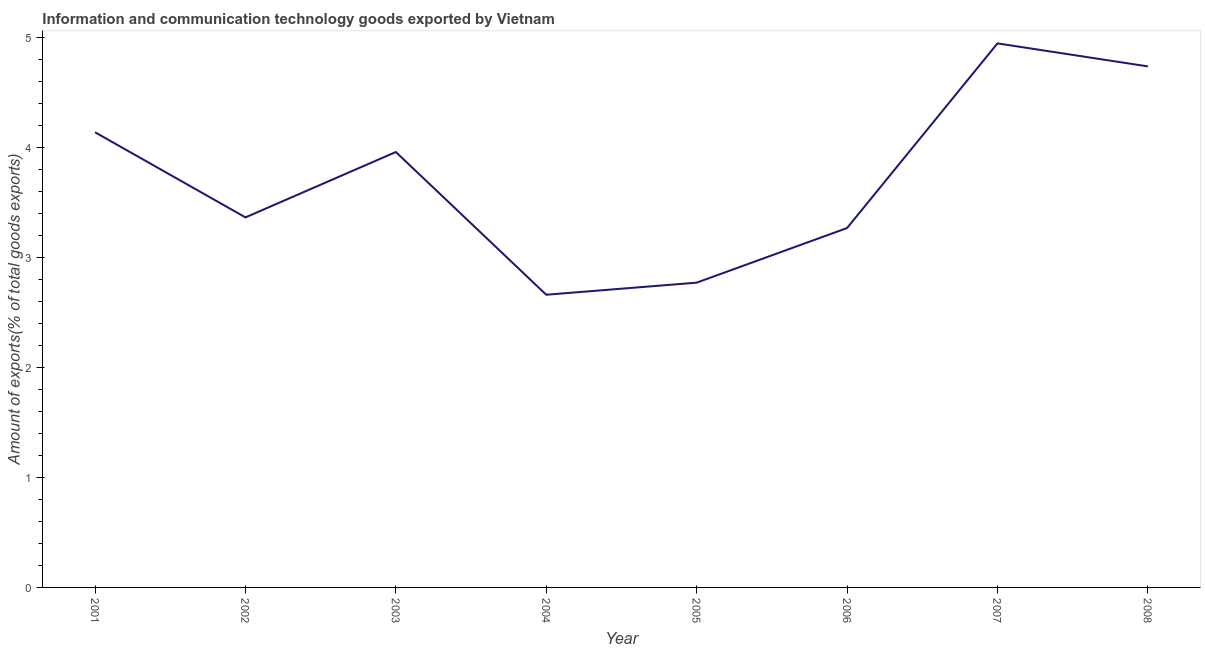What is the amount of ict goods exports in 2001?
Offer a very short reply. 4.14. Across all years, what is the maximum amount of ict goods exports?
Provide a succinct answer. 4.95. Across all years, what is the minimum amount of ict goods exports?
Offer a very short reply. 2.66. What is the sum of the amount of ict goods exports?
Offer a terse response. 29.85. What is the difference between the amount of ict goods exports in 2005 and 2008?
Your answer should be compact. -1.97. What is the average amount of ict goods exports per year?
Provide a succinct answer. 3.73. What is the median amount of ict goods exports?
Provide a succinct answer. 3.66. What is the ratio of the amount of ict goods exports in 2003 to that in 2004?
Make the answer very short. 1.49. What is the difference between the highest and the second highest amount of ict goods exports?
Offer a terse response. 0.21. Is the sum of the amount of ict goods exports in 2001 and 2006 greater than the maximum amount of ict goods exports across all years?
Your answer should be compact. Yes. What is the difference between the highest and the lowest amount of ict goods exports?
Offer a terse response. 2.29. In how many years, is the amount of ict goods exports greater than the average amount of ict goods exports taken over all years?
Provide a short and direct response. 4. Does the amount of ict goods exports monotonically increase over the years?
Offer a terse response. No. How many lines are there?
Offer a very short reply. 1. What is the difference between two consecutive major ticks on the Y-axis?
Provide a short and direct response. 1. Are the values on the major ticks of Y-axis written in scientific E-notation?
Your response must be concise. No. Does the graph contain any zero values?
Provide a short and direct response. No. What is the title of the graph?
Make the answer very short. Information and communication technology goods exported by Vietnam. What is the label or title of the X-axis?
Your answer should be very brief. Year. What is the label or title of the Y-axis?
Your answer should be very brief. Amount of exports(% of total goods exports). What is the Amount of exports(% of total goods exports) in 2001?
Make the answer very short. 4.14. What is the Amount of exports(% of total goods exports) of 2002?
Provide a succinct answer. 3.37. What is the Amount of exports(% of total goods exports) of 2003?
Make the answer very short. 3.96. What is the Amount of exports(% of total goods exports) of 2004?
Ensure brevity in your answer.  2.66. What is the Amount of exports(% of total goods exports) of 2005?
Provide a short and direct response. 2.77. What is the Amount of exports(% of total goods exports) in 2006?
Your answer should be very brief. 3.27. What is the Amount of exports(% of total goods exports) of 2007?
Keep it short and to the point. 4.95. What is the Amount of exports(% of total goods exports) in 2008?
Offer a very short reply. 4.74. What is the difference between the Amount of exports(% of total goods exports) in 2001 and 2002?
Make the answer very short. 0.77. What is the difference between the Amount of exports(% of total goods exports) in 2001 and 2003?
Your answer should be very brief. 0.18. What is the difference between the Amount of exports(% of total goods exports) in 2001 and 2004?
Your response must be concise. 1.48. What is the difference between the Amount of exports(% of total goods exports) in 2001 and 2005?
Your response must be concise. 1.37. What is the difference between the Amount of exports(% of total goods exports) in 2001 and 2006?
Your answer should be compact. 0.87. What is the difference between the Amount of exports(% of total goods exports) in 2001 and 2007?
Offer a very short reply. -0.81. What is the difference between the Amount of exports(% of total goods exports) in 2001 and 2008?
Give a very brief answer. -0.6. What is the difference between the Amount of exports(% of total goods exports) in 2002 and 2003?
Offer a very short reply. -0.59. What is the difference between the Amount of exports(% of total goods exports) in 2002 and 2004?
Your answer should be compact. 0.7. What is the difference between the Amount of exports(% of total goods exports) in 2002 and 2005?
Provide a short and direct response. 0.59. What is the difference between the Amount of exports(% of total goods exports) in 2002 and 2006?
Keep it short and to the point. 0.1. What is the difference between the Amount of exports(% of total goods exports) in 2002 and 2007?
Your response must be concise. -1.58. What is the difference between the Amount of exports(% of total goods exports) in 2002 and 2008?
Provide a short and direct response. -1.37. What is the difference between the Amount of exports(% of total goods exports) in 2003 and 2004?
Keep it short and to the point. 1.3. What is the difference between the Amount of exports(% of total goods exports) in 2003 and 2005?
Give a very brief answer. 1.19. What is the difference between the Amount of exports(% of total goods exports) in 2003 and 2006?
Offer a terse response. 0.69. What is the difference between the Amount of exports(% of total goods exports) in 2003 and 2007?
Ensure brevity in your answer.  -0.99. What is the difference between the Amount of exports(% of total goods exports) in 2003 and 2008?
Your answer should be very brief. -0.78. What is the difference between the Amount of exports(% of total goods exports) in 2004 and 2005?
Offer a terse response. -0.11. What is the difference between the Amount of exports(% of total goods exports) in 2004 and 2006?
Keep it short and to the point. -0.61. What is the difference between the Amount of exports(% of total goods exports) in 2004 and 2007?
Provide a short and direct response. -2.29. What is the difference between the Amount of exports(% of total goods exports) in 2004 and 2008?
Provide a short and direct response. -2.08. What is the difference between the Amount of exports(% of total goods exports) in 2005 and 2006?
Your answer should be compact. -0.5. What is the difference between the Amount of exports(% of total goods exports) in 2005 and 2007?
Your response must be concise. -2.18. What is the difference between the Amount of exports(% of total goods exports) in 2005 and 2008?
Your answer should be compact. -1.97. What is the difference between the Amount of exports(% of total goods exports) in 2006 and 2007?
Your response must be concise. -1.68. What is the difference between the Amount of exports(% of total goods exports) in 2006 and 2008?
Your answer should be compact. -1.47. What is the difference between the Amount of exports(% of total goods exports) in 2007 and 2008?
Your answer should be very brief. 0.21. What is the ratio of the Amount of exports(% of total goods exports) in 2001 to that in 2002?
Ensure brevity in your answer.  1.23. What is the ratio of the Amount of exports(% of total goods exports) in 2001 to that in 2003?
Your response must be concise. 1.04. What is the ratio of the Amount of exports(% of total goods exports) in 2001 to that in 2004?
Provide a short and direct response. 1.55. What is the ratio of the Amount of exports(% of total goods exports) in 2001 to that in 2005?
Offer a very short reply. 1.49. What is the ratio of the Amount of exports(% of total goods exports) in 2001 to that in 2006?
Provide a succinct answer. 1.27. What is the ratio of the Amount of exports(% of total goods exports) in 2001 to that in 2007?
Your answer should be compact. 0.84. What is the ratio of the Amount of exports(% of total goods exports) in 2001 to that in 2008?
Your answer should be very brief. 0.87. What is the ratio of the Amount of exports(% of total goods exports) in 2002 to that in 2004?
Your answer should be very brief. 1.26. What is the ratio of the Amount of exports(% of total goods exports) in 2002 to that in 2005?
Provide a succinct answer. 1.21. What is the ratio of the Amount of exports(% of total goods exports) in 2002 to that in 2007?
Offer a terse response. 0.68. What is the ratio of the Amount of exports(% of total goods exports) in 2002 to that in 2008?
Keep it short and to the point. 0.71. What is the ratio of the Amount of exports(% of total goods exports) in 2003 to that in 2004?
Your response must be concise. 1.49. What is the ratio of the Amount of exports(% of total goods exports) in 2003 to that in 2005?
Offer a terse response. 1.43. What is the ratio of the Amount of exports(% of total goods exports) in 2003 to that in 2006?
Your answer should be very brief. 1.21. What is the ratio of the Amount of exports(% of total goods exports) in 2003 to that in 2008?
Offer a terse response. 0.84. What is the ratio of the Amount of exports(% of total goods exports) in 2004 to that in 2006?
Ensure brevity in your answer.  0.81. What is the ratio of the Amount of exports(% of total goods exports) in 2004 to that in 2007?
Your answer should be very brief. 0.54. What is the ratio of the Amount of exports(% of total goods exports) in 2004 to that in 2008?
Ensure brevity in your answer.  0.56. What is the ratio of the Amount of exports(% of total goods exports) in 2005 to that in 2006?
Ensure brevity in your answer.  0.85. What is the ratio of the Amount of exports(% of total goods exports) in 2005 to that in 2007?
Your answer should be compact. 0.56. What is the ratio of the Amount of exports(% of total goods exports) in 2005 to that in 2008?
Provide a short and direct response. 0.58. What is the ratio of the Amount of exports(% of total goods exports) in 2006 to that in 2007?
Your answer should be compact. 0.66. What is the ratio of the Amount of exports(% of total goods exports) in 2006 to that in 2008?
Your response must be concise. 0.69. What is the ratio of the Amount of exports(% of total goods exports) in 2007 to that in 2008?
Offer a terse response. 1.04. 